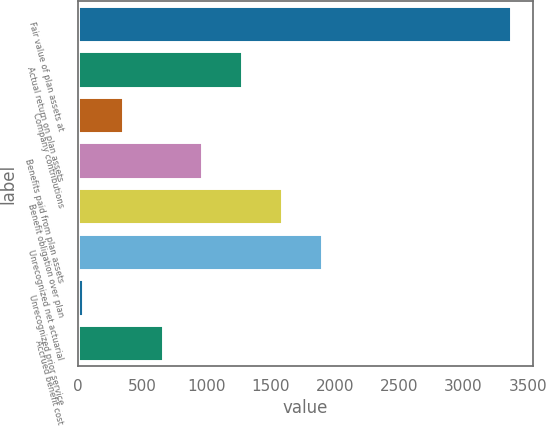Convert chart to OTSL. <chart><loc_0><loc_0><loc_500><loc_500><bar_chart><fcel>Fair value of plan assets at<fcel>Actual return on plan assets<fcel>Company contributions<fcel>Benefits paid from plan assets<fcel>Benefit obligation over plan<fcel>Unrecognized net actuarial<fcel>Unrecognized prior service<fcel>Accrued benefit cost<nl><fcel>3371.97<fcel>1278.78<fcel>351.87<fcel>969.81<fcel>1587.75<fcel>1896.72<fcel>42.9<fcel>660.84<nl></chart> 